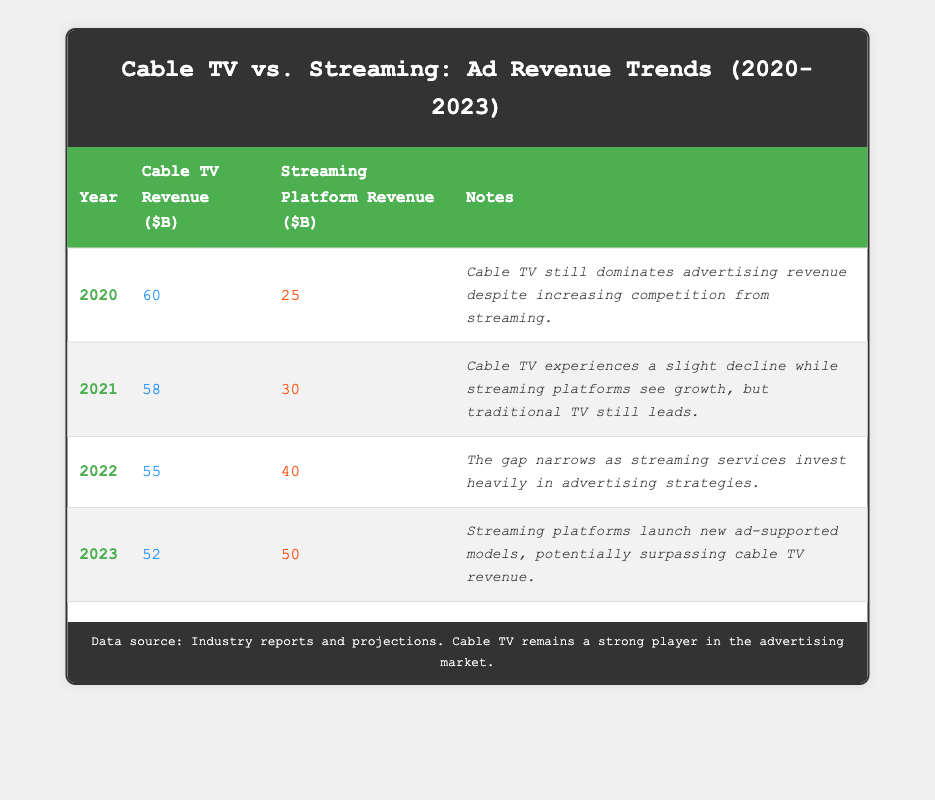What was the advertising revenue for Cable TV in 2020? According to the table, the revenue for Cable TV in 2020 is clearly listed as 60 billion dollars.
Answer: 60 What was the trend in Cable TV revenue from 2020 to 2023? Examining the Cable TV revenue for the years provided: 60 (2020), 58 (2021), 55 (2022), and 52 (2023), we can observe a consistent decline each year.
Answer: Decline What is the total advertising revenue for Streaming Platforms from 2020 to 2023? To find the total, we sum the Streaming Platform revenue for each year: 25 (2020) + 30 (2021) + 40 (2022) + 50 (2023) = 145 billion dollars.
Answer: 145 Did Cable TV revenue ever exceed Streaming Platform revenue from 2020 to 2023? By comparing the revenues for each year, Cable TV revenue exceeded Streaming Platform revenue in 2020, 2021, and 2022, but not in 2023 where Streaming revenue exceeded Cable TV revenue.
Answer: Yes What was the average revenue of Cable TV over the four years? We can calculate the average by summing the revenues for Cable TV: 60 + 58 + 55 + 52 = 225 billion dollars. Dividing this total by the number of years (4) gives 225 / 4 = 56.25 billion dollars.
Answer: 56.25 